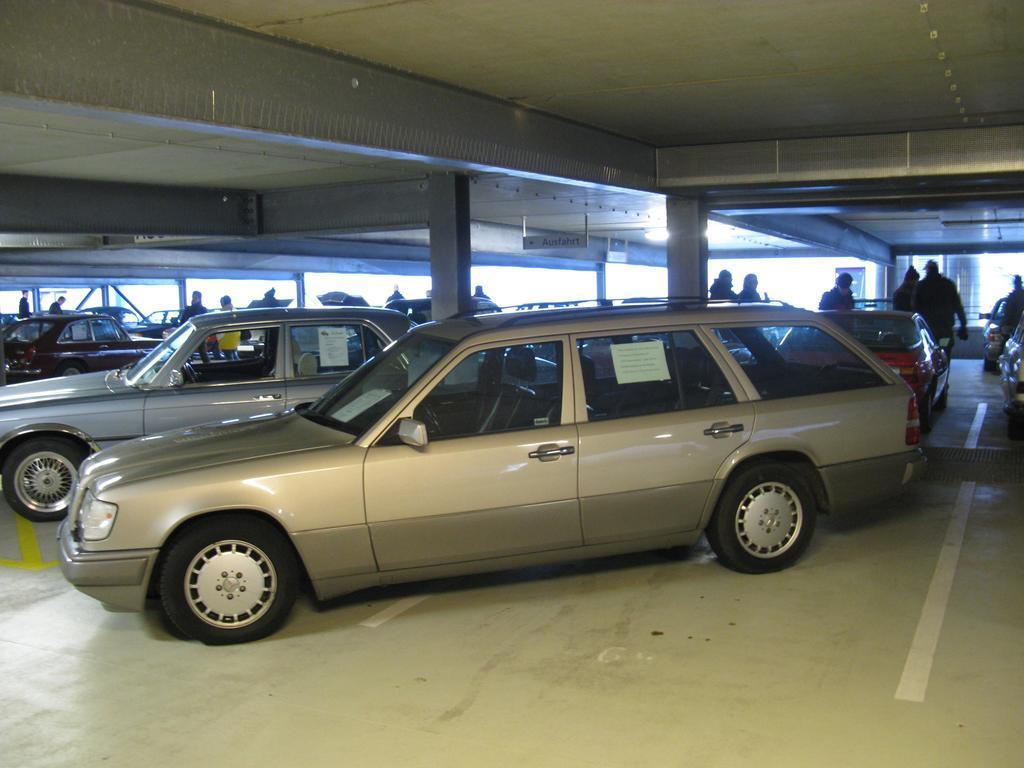In one or two sentences, can you explain what this image depicts? In this image we can see cars, people and pillars. 